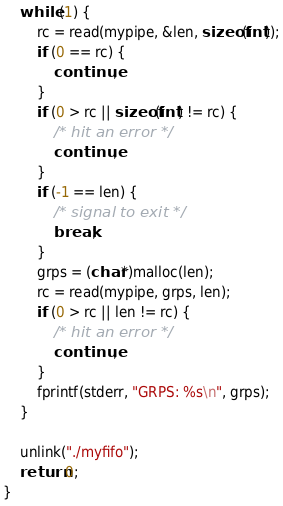<code> <loc_0><loc_0><loc_500><loc_500><_C_>    while (1) {
        rc = read(mypipe, &len, sizeof(int));
        if (0 == rc) {
            continue;
        }
        if (0 > rc || sizeof(int) != rc) {
            /* hit an error */
            continue;
        }
        if (-1 == len) {
            /* signal to exit */
            break;
        }
        grps = (char*)malloc(len);
        rc = read(mypipe, grps, len);
        if (0 > rc || len != rc) {
            /* hit an error */
            continue;
        }
        fprintf(stderr, "GRPS: %s\n", grps);
    }

    unlink("./myfifo");
    return 0;
}
</code> 